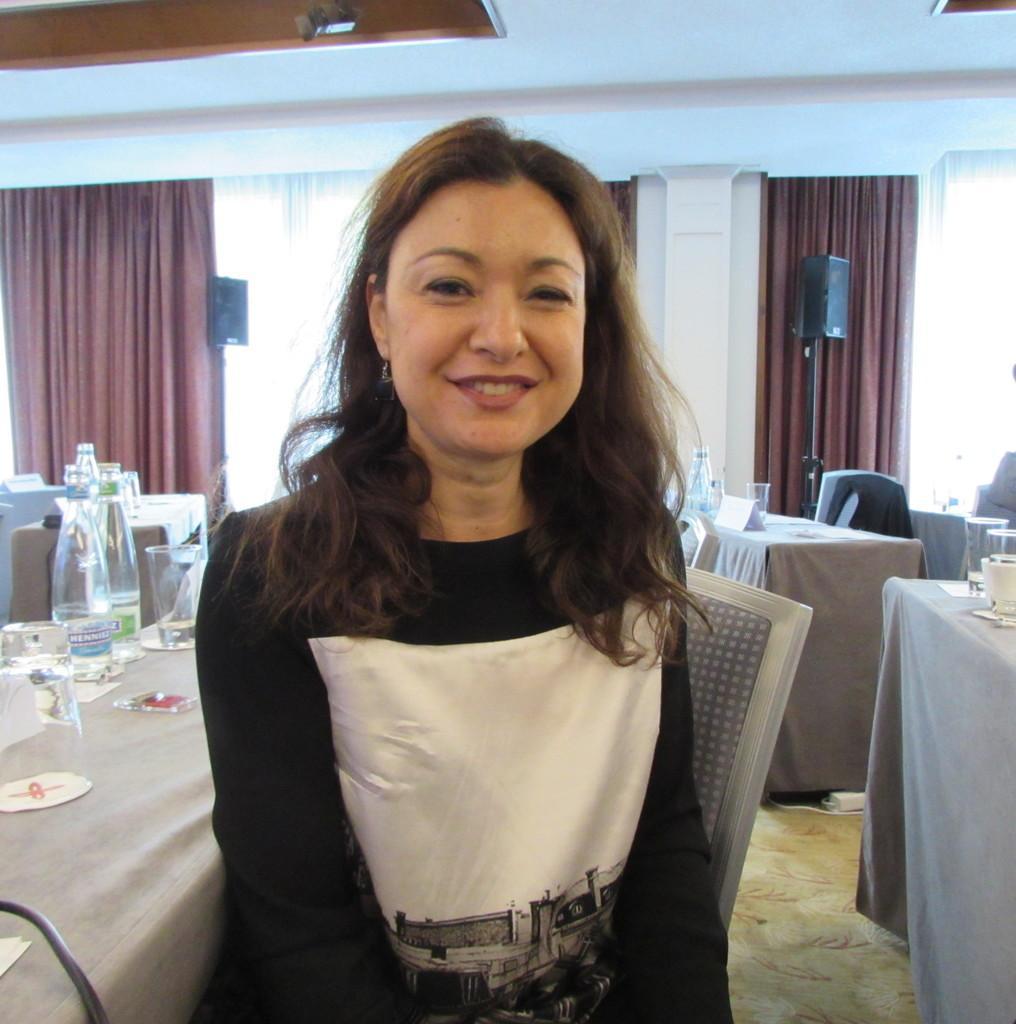In one or two sentences, can you explain what this image depicts? This Image is clicked in a restaurant. There are so many chairs and tables and there is a curtain on the back side. On the table there are water bottles, Glasses and woman is sitting on the chair. 